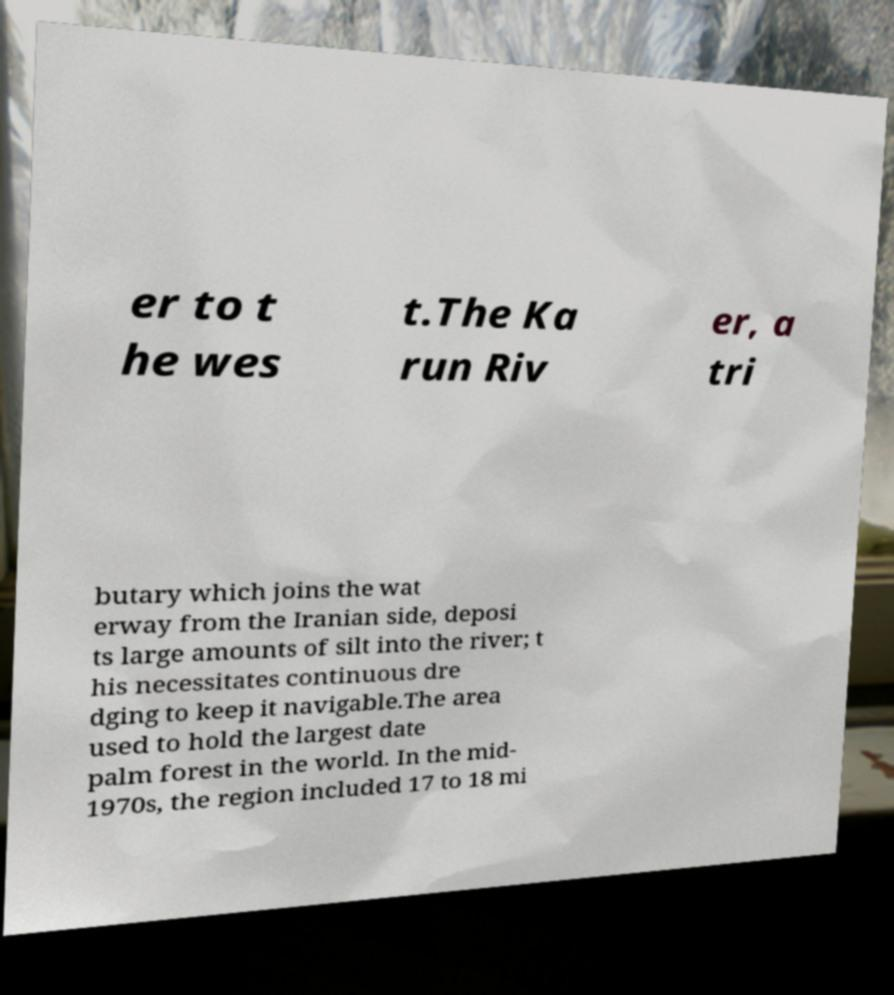Please identify and transcribe the text found in this image. er to t he wes t.The Ka run Riv er, a tri butary which joins the wat erway from the Iranian side, deposi ts large amounts of silt into the river; t his necessitates continuous dre dging to keep it navigable.The area used to hold the largest date palm forest in the world. In the mid- 1970s, the region included 17 to 18 mi 